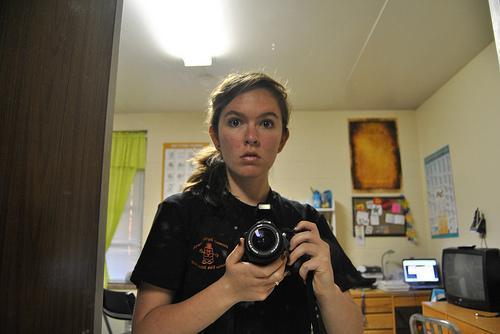How many cameras are there?
Give a very brief answer. 1. 